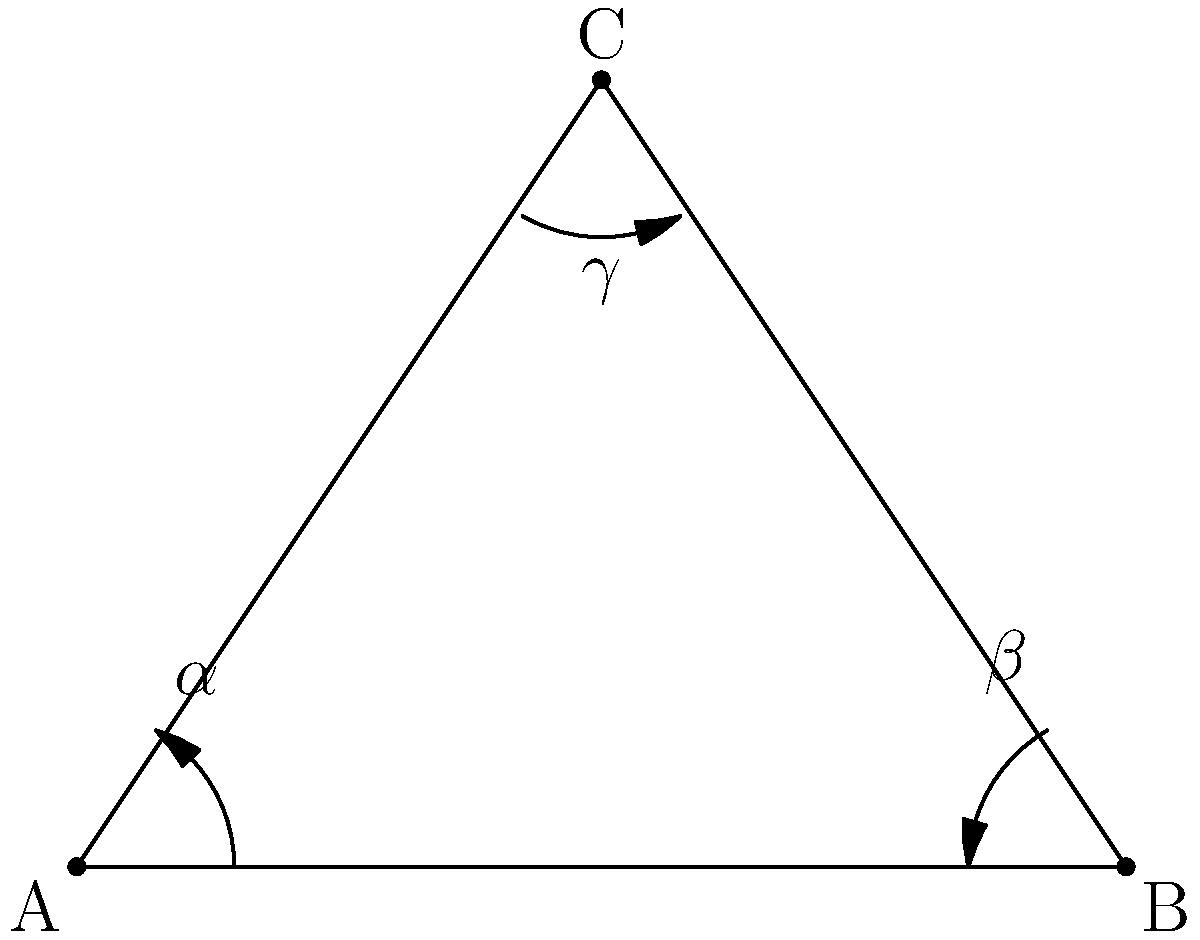In the diagram above, three stick figures represent different tennis serve techniques. The angles $\alpha$, $\beta$, and $\gamma$ correspond to the arm positions during the serve motion. If $\alpha + \beta + \gamma = 180°$, which angle is likely to represent the final position of a powerful serve, and approximately how many degrees would it be? To answer this question, we need to consider the biomechanics of a powerful tennis serve and the properties of triangles:

1. In a triangle, the sum of all interior angles is always 180°. This matches the given condition $\alpha + \beta + \gamma = 180°$.

2. A powerful tennis serve typically involves an overhead motion where the arm is extended upwards and slightly behind the head at the point of contact with the ball.

3. This position would correspond to the largest angle in the triangle, as it requires the most extension.

4. In the diagram, angle $\gamma$ at the top of the triangle appears to be the largest, making it the most likely candidate for the final position of a powerful serve.

5. To estimate the size of $\gamma$, we can use our knowledge of common triangle angles:
   - An equilateral triangle has all angles equal to 60°
   - A right triangle has one 90° angle and two 45° angles (if isosceles)

6. The angle $\gamma$ appears larger than 60° but less than 90°, suggesting it's likely between 70° and 80°.

7. Given that powerful serves often involve an arm position slightly behind vertical, an angle of approximately 75° would be a reasonable estimate.
Answer: $\gamma$, approximately 75° 